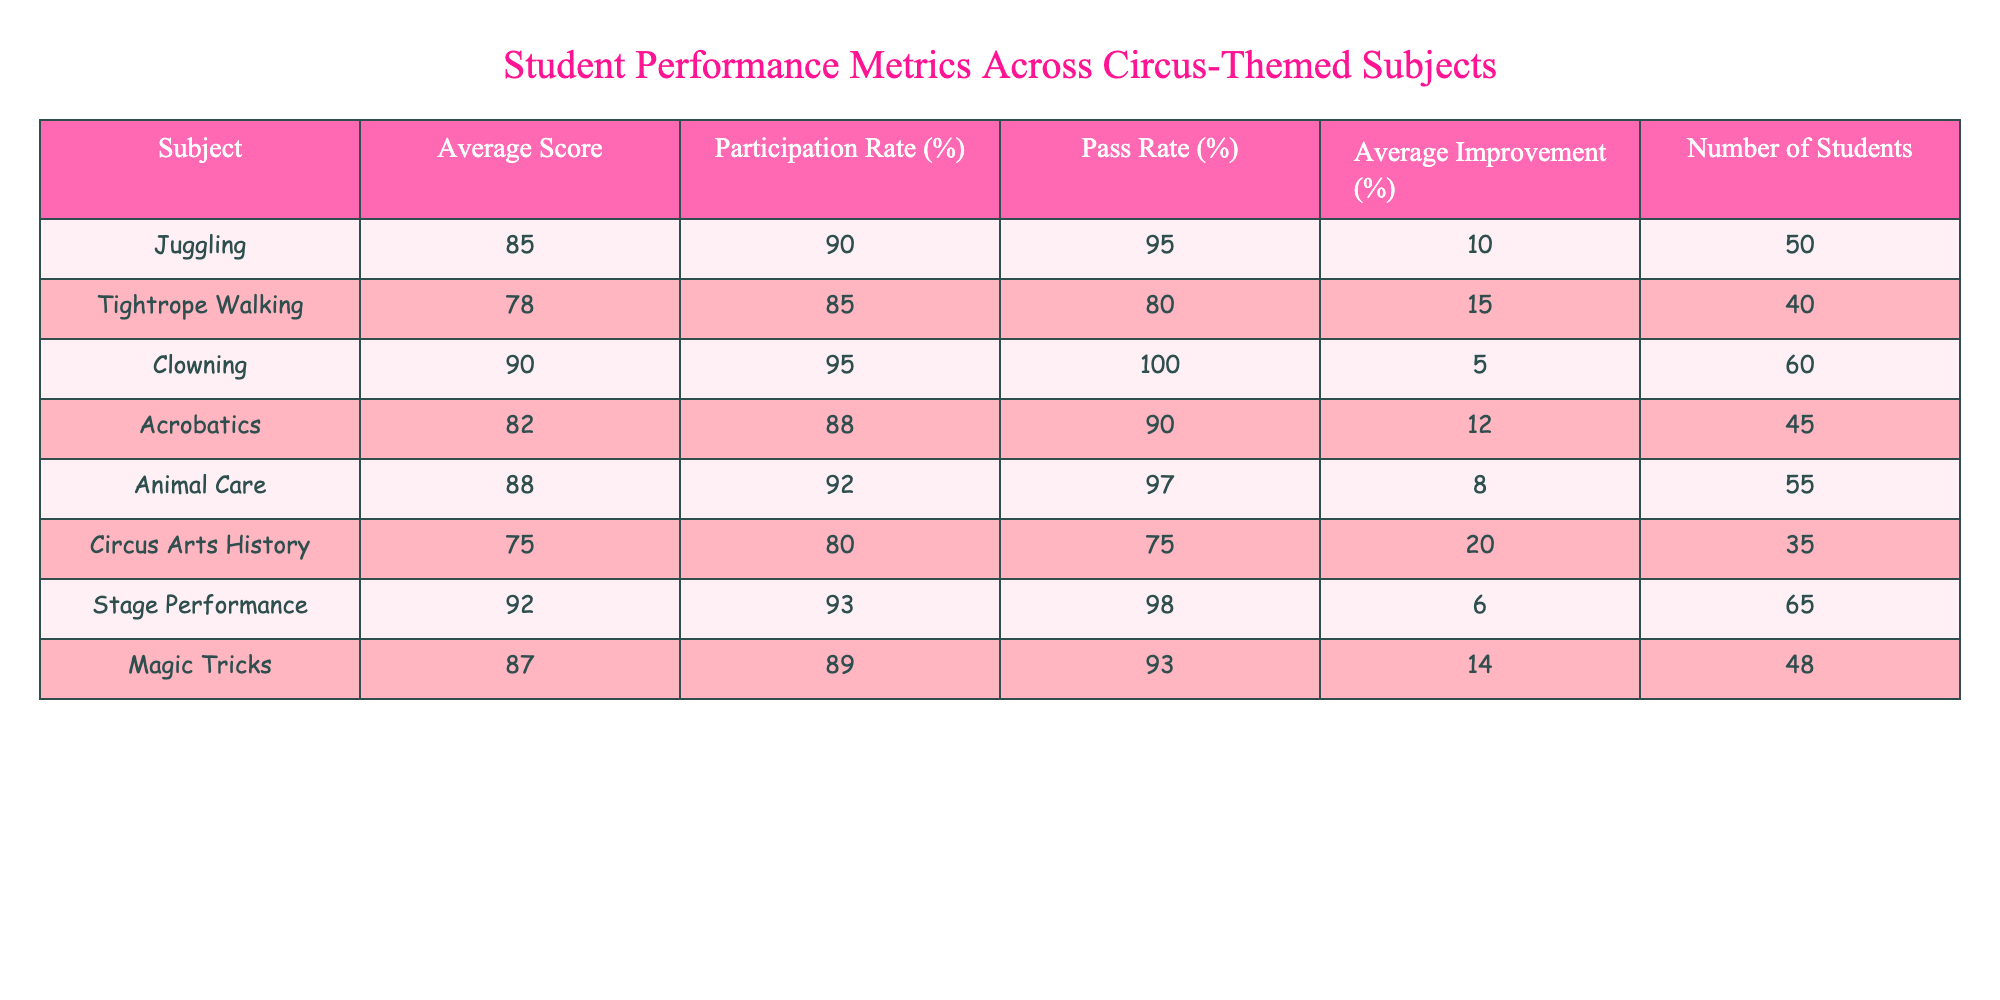What is the average score for Juggling? The table shows that the average score for Juggling is listed directly under the Average Score column. It states 85.
Answer: 85 What is the participation rate for Circus Arts History? The table displays that the participation rate for Circus Arts History can be found in the Participation Rate (%) column, which is 80%.
Answer: 80% Which subject has the highest pass rate? By reviewing the Pass Rate (%) column, we see that Clowning has a pass rate of 100%, which is the highest compared to other subjects.
Answer: Clowning What is the combined participation rate for Juggling and Tightrope Walking? The participation rates for Juggling (90%) and Tightrope Walking (85%) can be combined by adding them together: 90 + 85 = 175. To find the average, divide by 2: 175 / 2 = 87.5%.
Answer: 87.5 Is the average improvement for Animal Care greater than 10%? The average improvement for Animal Care is stated as 8%. Since 8% is less than 10%, the statement is false.
Answer: No What is the number of students enrolled in the subject with the lowest average score? The lowest average score is found in Circus Arts History, which has 35 students enrolled according to the Number of Students column.
Answer: 35 Which two subjects have an average improvement greater than 10%? Looking at the Average Improvement (%) column, we see that Tightrope Walking (15%) and Magic Tricks (14%) both exceed 10%.
Answer: Tightrope Walking and Magic Tricks What is the average score of subjects with a participation rate greater than 90%? The subjects with participation rates over 90% are Juggling (85), Clowning (90), and Animal Care (88). Adding these up gives 85 + 90 + 88 = 263. There are 3 subjects, so the average is 263 / 3 = 87.67.
Answer: 87.67 Which subject has a pass rate lower than 90% and what is its average score? The subjects with a pass rate lower than 90% are Tightrope Walking (80%) and Circus Arts History (75%). Their average scores are 78 and 75, respectively.
Answer: Tightrope Walking: 78, Circus Arts History: 75 